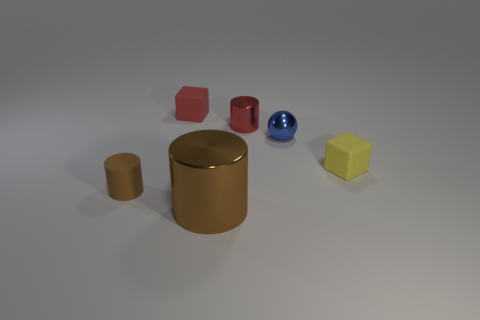Is there a particular color scheme or pattern to the arrangement of the objects? Not specifically; the objects are arranged randomly and include colors such as red, blue, yellow, and shades of brown without a discernible pattern or color scheme. 